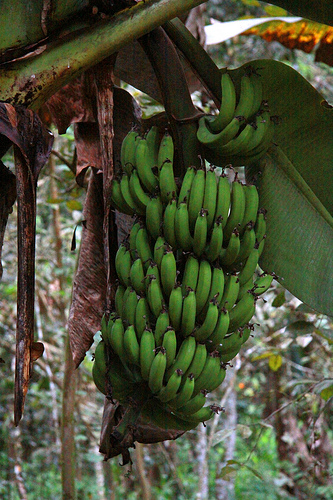Describe a typical day in the life of a banana in this bunch. From sunrise, basking in the morning light, a day in the life of a banana involves soaking up sunlight to continue its growth process. By noon, it might face tropical rains that provide much-needed hydration. As the day progresses, the banana receives nutrients from the plant, helping it to mature and eventually ripen. Nighttime brings cooler temperatures, allowing the banana to rest and rejuvenate for the next day. Throughout, the banana occasionally deals with wildlife interactions, from curious insects to potential predators, all playing a role in its journey towards maturity. What stories might the banana tell about its surroundings? The banana would share tales of the bustling activity of the forest, each day being a new adventure. They might speak of squirrels that dart by, the melodies of birds perched on the tree, and the whispering winds carrying secrets from afar. They would narrate encounters with curious insects, some friends, others foes. The banana would recall the nurturing rains and the warming sun, both essential for its growth. It would also tell of the changing seasons, how some leaves age while new ones sprout, showcasing the cycle of life in its lush habitat. 